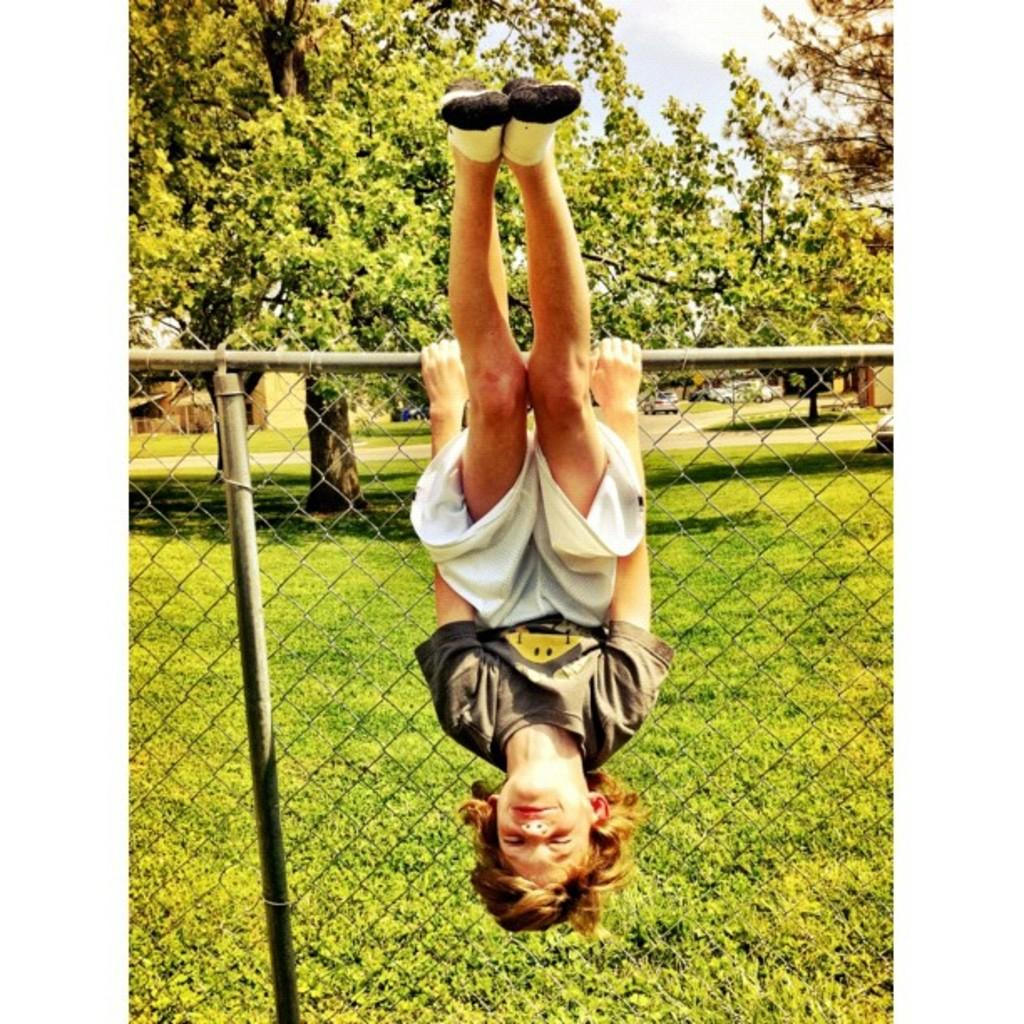What is the main subject of the image? There is a child in the image. What is the child doing in the image? The child is hanging upside down. How is the child hanging upside down? The child is supported by a fence. What type of natural environment is visible in the image? There are trees and grass in the image. What else can be seen in the image besides the child? There are vehicles and the sky visible in the image. What type of wool is being used by the snails in the image? There are no snails or wool present in the image. What kind of apparatus is the child using to hang upside down? The child is not using any specific apparatus to hang upside down; they are supported by a fence. 